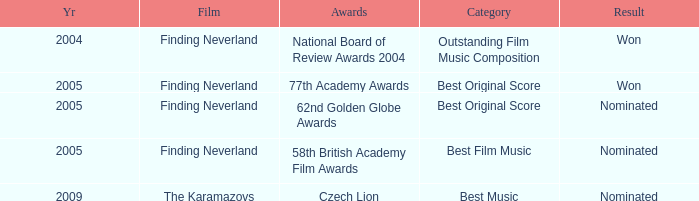Which awards happened more recently than 2005? Czech Lion. 